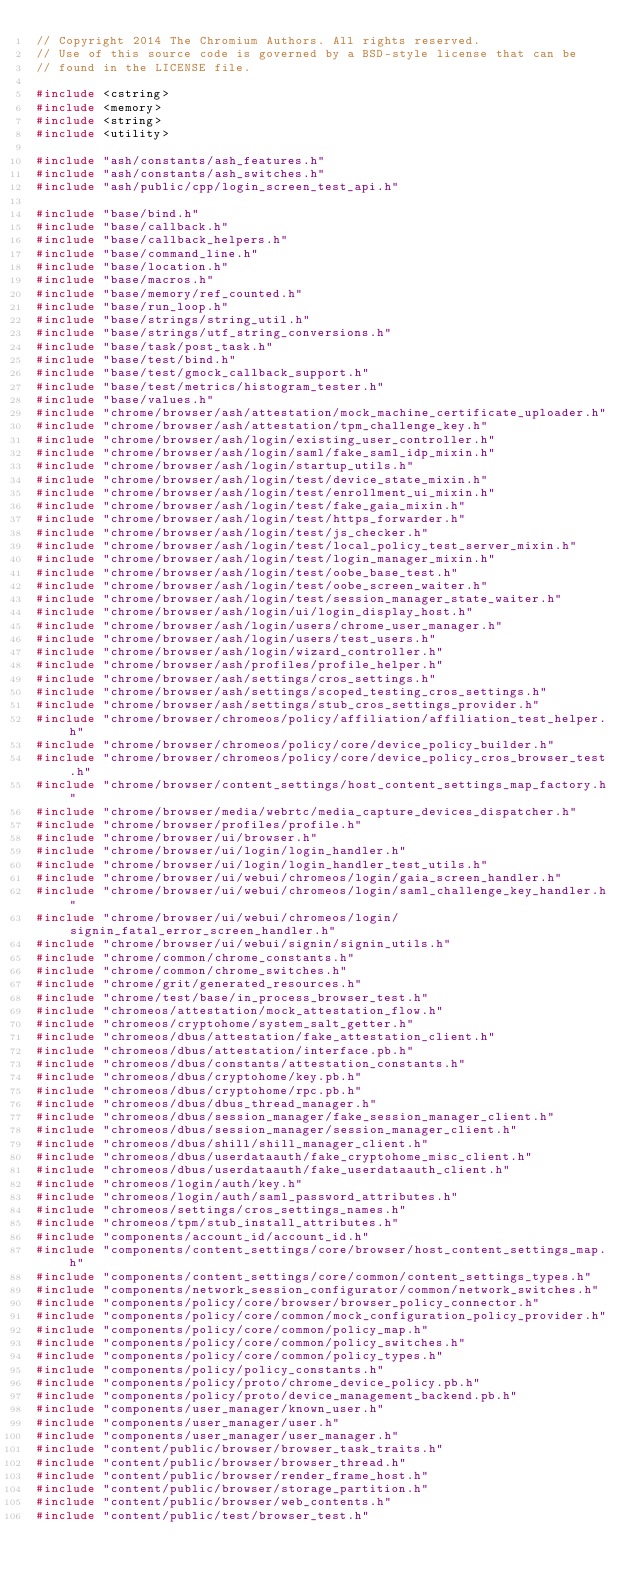<code> <loc_0><loc_0><loc_500><loc_500><_C++_>// Copyright 2014 The Chromium Authors. All rights reserved.
// Use of this source code is governed by a BSD-style license that can be
// found in the LICENSE file.

#include <cstring>
#include <memory>
#include <string>
#include <utility>

#include "ash/constants/ash_features.h"
#include "ash/constants/ash_switches.h"
#include "ash/public/cpp/login_screen_test_api.h"

#include "base/bind.h"
#include "base/callback.h"
#include "base/callback_helpers.h"
#include "base/command_line.h"
#include "base/location.h"
#include "base/macros.h"
#include "base/memory/ref_counted.h"
#include "base/run_loop.h"
#include "base/strings/string_util.h"
#include "base/strings/utf_string_conversions.h"
#include "base/task/post_task.h"
#include "base/test/bind.h"
#include "base/test/gmock_callback_support.h"
#include "base/test/metrics/histogram_tester.h"
#include "base/values.h"
#include "chrome/browser/ash/attestation/mock_machine_certificate_uploader.h"
#include "chrome/browser/ash/attestation/tpm_challenge_key.h"
#include "chrome/browser/ash/login/existing_user_controller.h"
#include "chrome/browser/ash/login/saml/fake_saml_idp_mixin.h"
#include "chrome/browser/ash/login/startup_utils.h"
#include "chrome/browser/ash/login/test/device_state_mixin.h"
#include "chrome/browser/ash/login/test/enrollment_ui_mixin.h"
#include "chrome/browser/ash/login/test/fake_gaia_mixin.h"
#include "chrome/browser/ash/login/test/https_forwarder.h"
#include "chrome/browser/ash/login/test/js_checker.h"
#include "chrome/browser/ash/login/test/local_policy_test_server_mixin.h"
#include "chrome/browser/ash/login/test/login_manager_mixin.h"
#include "chrome/browser/ash/login/test/oobe_base_test.h"
#include "chrome/browser/ash/login/test/oobe_screen_waiter.h"
#include "chrome/browser/ash/login/test/session_manager_state_waiter.h"
#include "chrome/browser/ash/login/ui/login_display_host.h"
#include "chrome/browser/ash/login/users/chrome_user_manager.h"
#include "chrome/browser/ash/login/users/test_users.h"
#include "chrome/browser/ash/login/wizard_controller.h"
#include "chrome/browser/ash/profiles/profile_helper.h"
#include "chrome/browser/ash/settings/cros_settings.h"
#include "chrome/browser/ash/settings/scoped_testing_cros_settings.h"
#include "chrome/browser/ash/settings/stub_cros_settings_provider.h"
#include "chrome/browser/chromeos/policy/affiliation/affiliation_test_helper.h"
#include "chrome/browser/chromeos/policy/core/device_policy_builder.h"
#include "chrome/browser/chromeos/policy/core/device_policy_cros_browser_test.h"
#include "chrome/browser/content_settings/host_content_settings_map_factory.h"
#include "chrome/browser/media/webrtc/media_capture_devices_dispatcher.h"
#include "chrome/browser/profiles/profile.h"
#include "chrome/browser/ui/browser.h"
#include "chrome/browser/ui/login/login_handler.h"
#include "chrome/browser/ui/login/login_handler_test_utils.h"
#include "chrome/browser/ui/webui/chromeos/login/gaia_screen_handler.h"
#include "chrome/browser/ui/webui/chromeos/login/saml_challenge_key_handler.h"
#include "chrome/browser/ui/webui/chromeos/login/signin_fatal_error_screen_handler.h"
#include "chrome/browser/ui/webui/signin/signin_utils.h"
#include "chrome/common/chrome_constants.h"
#include "chrome/common/chrome_switches.h"
#include "chrome/grit/generated_resources.h"
#include "chrome/test/base/in_process_browser_test.h"
#include "chromeos/attestation/mock_attestation_flow.h"
#include "chromeos/cryptohome/system_salt_getter.h"
#include "chromeos/dbus/attestation/fake_attestation_client.h"
#include "chromeos/dbus/attestation/interface.pb.h"
#include "chromeos/dbus/constants/attestation_constants.h"
#include "chromeos/dbus/cryptohome/key.pb.h"
#include "chromeos/dbus/cryptohome/rpc.pb.h"
#include "chromeos/dbus/dbus_thread_manager.h"
#include "chromeos/dbus/session_manager/fake_session_manager_client.h"
#include "chromeos/dbus/session_manager/session_manager_client.h"
#include "chromeos/dbus/shill/shill_manager_client.h"
#include "chromeos/dbus/userdataauth/fake_cryptohome_misc_client.h"
#include "chromeos/dbus/userdataauth/fake_userdataauth_client.h"
#include "chromeos/login/auth/key.h"
#include "chromeos/login/auth/saml_password_attributes.h"
#include "chromeos/settings/cros_settings_names.h"
#include "chromeos/tpm/stub_install_attributes.h"
#include "components/account_id/account_id.h"
#include "components/content_settings/core/browser/host_content_settings_map.h"
#include "components/content_settings/core/common/content_settings_types.h"
#include "components/network_session_configurator/common/network_switches.h"
#include "components/policy/core/browser/browser_policy_connector.h"
#include "components/policy/core/common/mock_configuration_policy_provider.h"
#include "components/policy/core/common/policy_map.h"
#include "components/policy/core/common/policy_switches.h"
#include "components/policy/core/common/policy_types.h"
#include "components/policy/policy_constants.h"
#include "components/policy/proto/chrome_device_policy.pb.h"
#include "components/policy/proto/device_management_backend.pb.h"
#include "components/user_manager/known_user.h"
#include "components/user_manager/user.h"
#include "components/user_manager/user_manager.h"
#include "content/public/browser/browser_task_traits.h"
#include "content/public/browser/browser_thread.h"
#include "content/public/browser/render_frame_host.h"
#include "content/public/browser/storage_partition.h"
#include "content/public/browser/web_contents.h"
#include "content/public/test/browser_test.h"</code> 